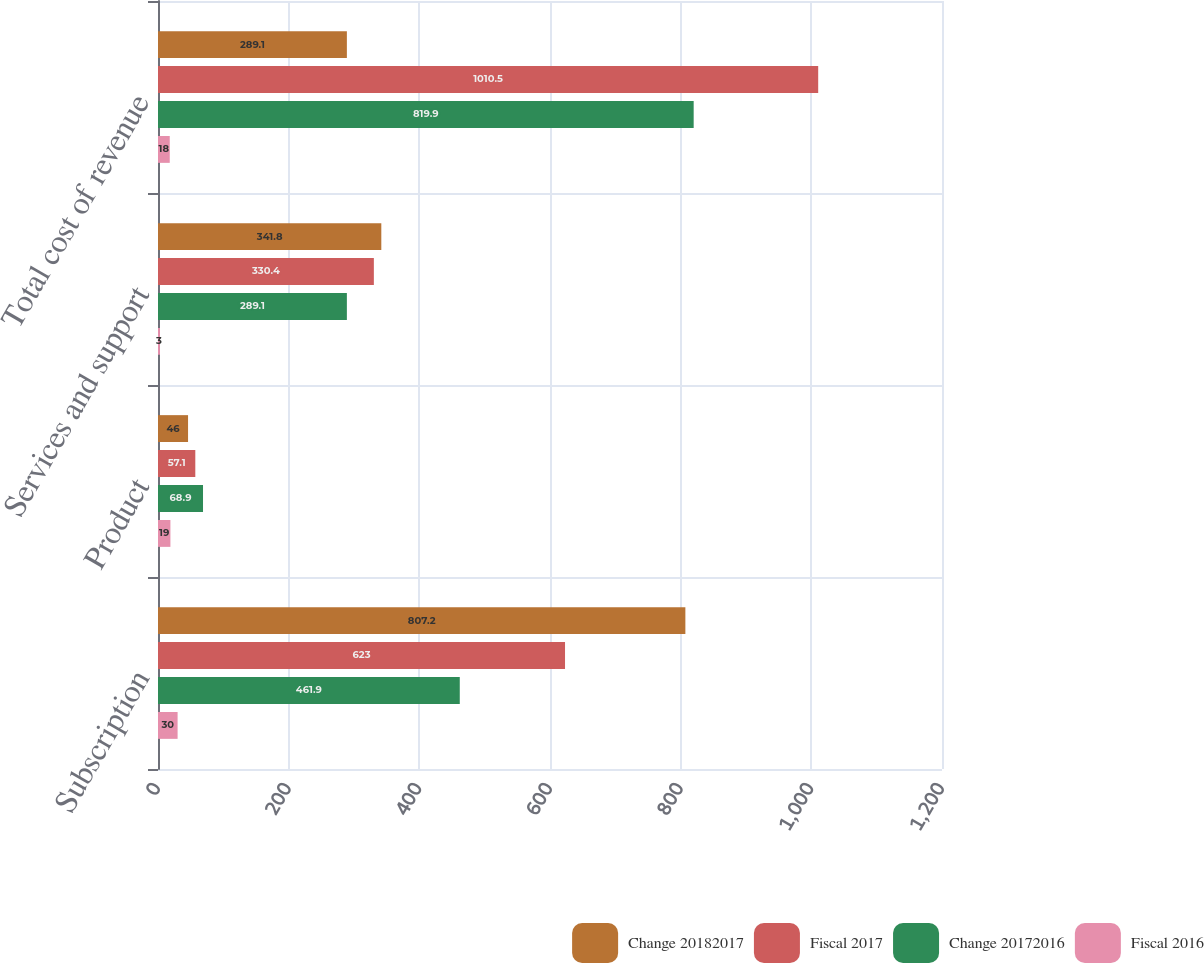Convert chart. <chart><loc_0><loc_0><loc_500><loc_500><stacked_bar_chart><ecel><fcel>Subscription<fcel>Product<fcel>Services and support<fcel>Total cost of revenue<nl><fcel>Change 20182017<fcel>807.2<fcel>46<fcel>341.8<fcel>289.1<nl><fcel>Fiscal 2017<fcel>623<fcel>57.1<fcel>330.4<fcel>1010.5<nl><fcel>Change 20172016<fcel>461.9<fcel>68.9<fcel>289.1<fcel>819.9<nl><fcel>Fiscal 2016<fcel>30<fcel>19<fcel>3<fcel>18<nl></chart> 